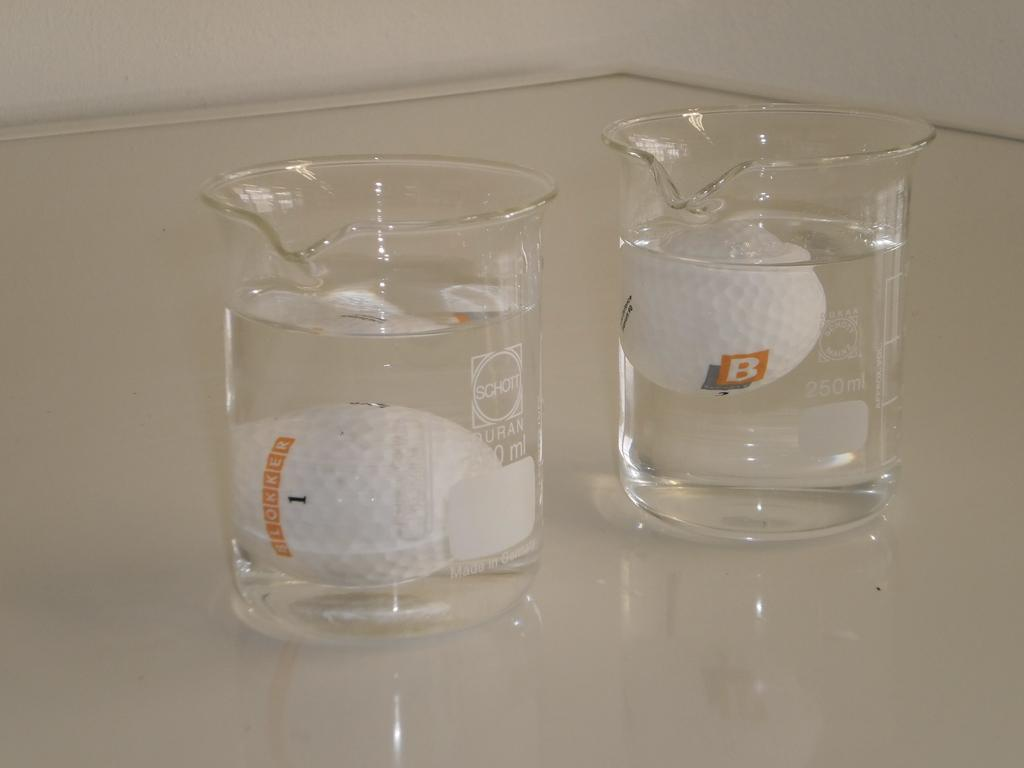Provide a one-sentence caption for the provided image. Glass beaker by Schott with golf ball inside. 